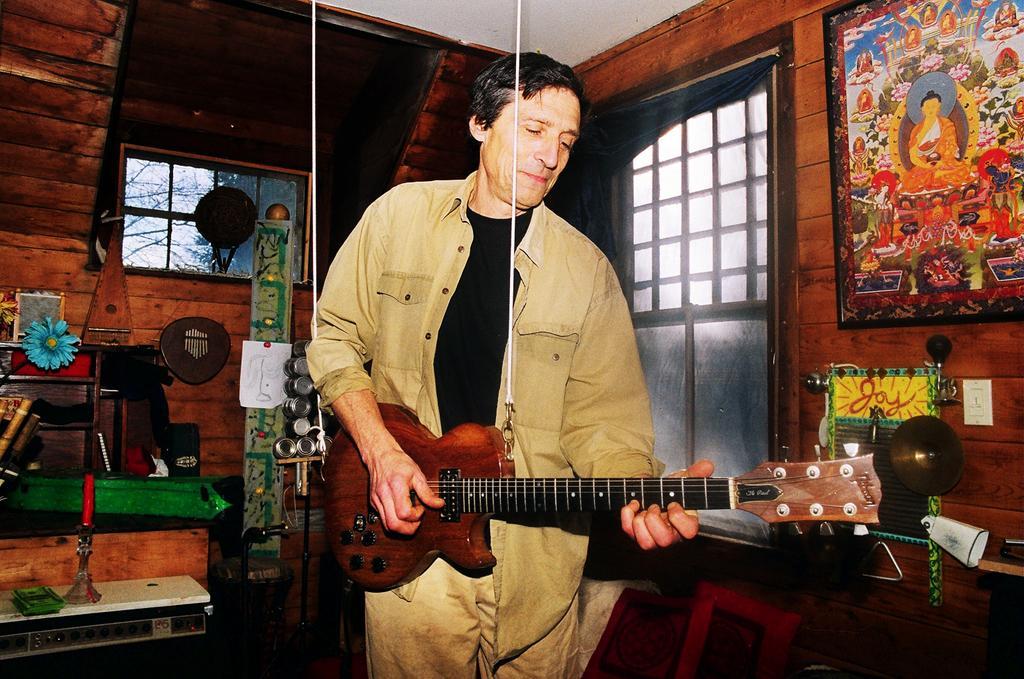Please provide a concise description of this image. In this picture we can see a man wearing brown shirt and black T- shirt playing a guitar, on the right side of wall we have painting and in center straight we can see a window and tree behind that. On the left corner we have wooden table and a green packet on a blue color flower is placed. 